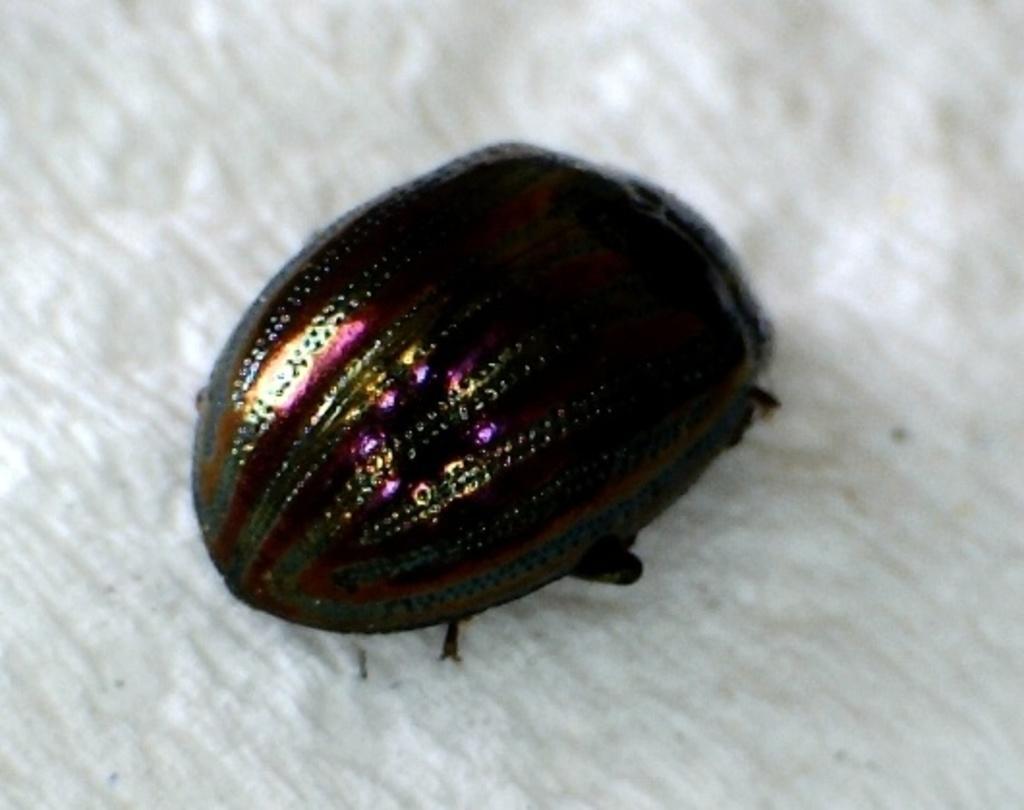In one or two sentences, can you explain what this image depicts? In picture I can see the insect on the white color blanket or other object. 